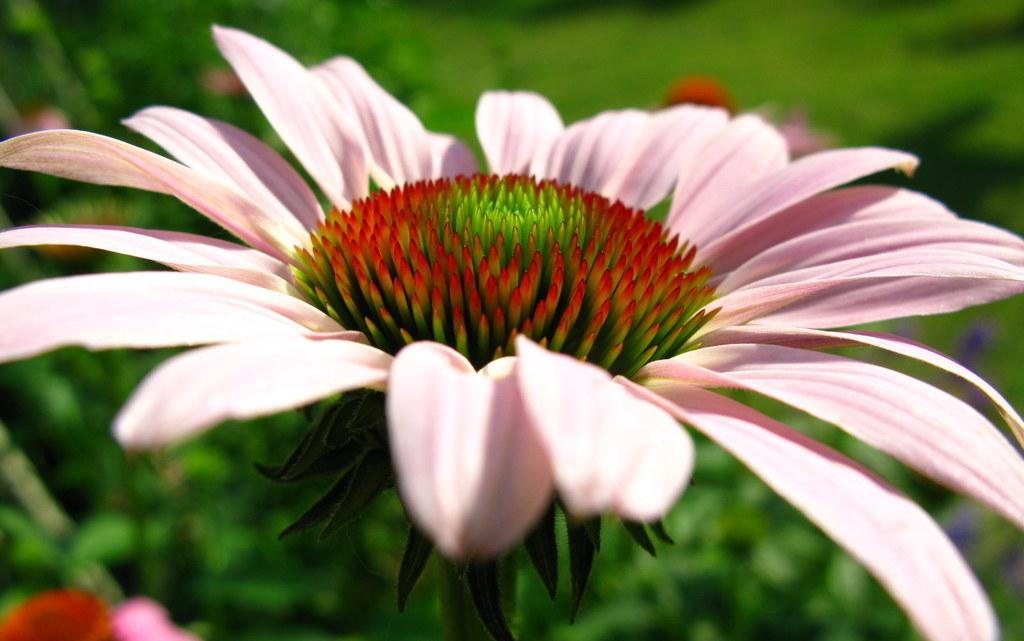What types of flowers can be seen in the image? There are flowers of different colors in the image. What can be seen in the background of the image? The background of the image includes grass. How would you describe the appearance of the background? The background appears blurry. Can you tell me how many rifles are visible in the image? There are no rifles present in the image; it features flowers and a blurry grass background. 